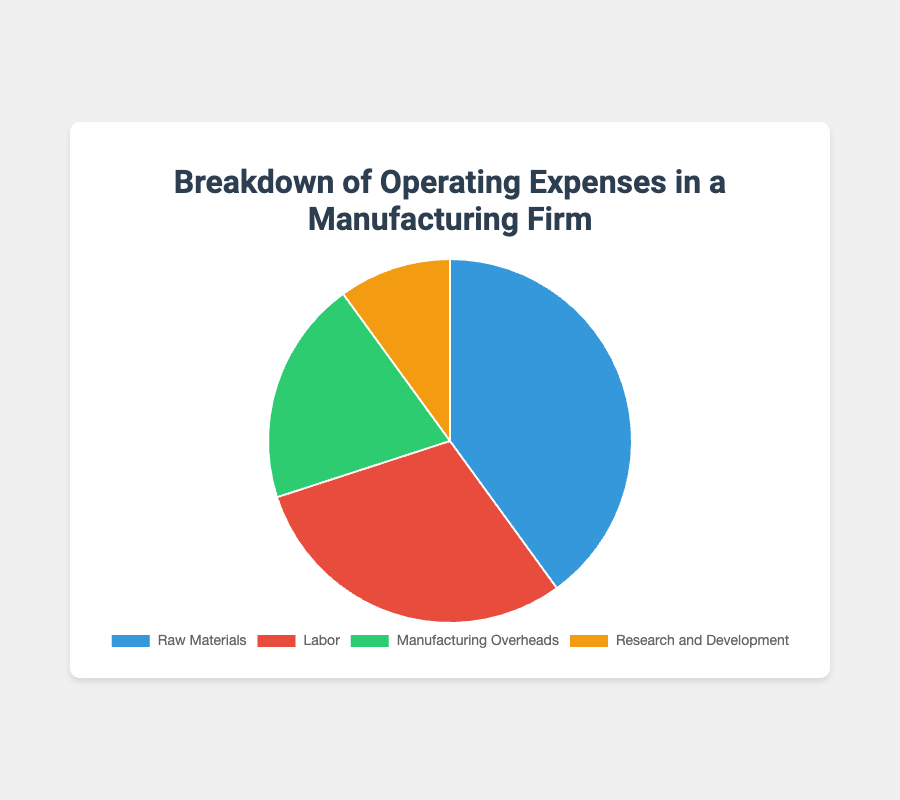What percentage of the total operating expenses is attributed to Labor and Research and Development combined? First, find the percentages for Labor (30%) and Research and Development (10%). Then, sum these percentages: 30% + 10% = 40%.
Answer: 40% Which category accounts for the highest proportion of operating expenses? Look at the percentages for each category and identify the highest value. Raw Materials have the highest percentage at 40%.
Answer: Raw Materials How much more is spent on Raw Materials compared to Manufacturing Overheads? Find the difference between the percentages for Raw Materials (40%) and Manufacturing Overheads (20%): 40% - 20% = 20%.
Answer: 20% Which category is represented by the green color in the pie chart? Look at the dataset and identify that Manufacturing Overheads is assigned the green color.
Answer: Manufacturing Overheads Rank the categories from highest to lowest percentage of operating expenses. List the categories by their given percentages: Raw Materials (40%), Labor (30%), Manufacturing Overheads (20%), Research and Development (10%).
Answer: Raw Materials, Labor, Manufacturing Overheads, Research and Development What is the difference in percentage points between the largest and smallest expense categories? Identify the highest (Raw Materials, 40%) and the lowest (Research and Development, 10%) percentages. Calculate the difference: 40% - 10% = 30%.
Answer: 30% Which two categories together account for half of the total operating expenses? Find two categories that sum to 50%. Labor (30%) and Manufacturing Overheads (20%) together account for 50%: 30% + 20% = 50%.
Answer: Labor and Manufacturing Overheads What is the combined percentage of all categories except Raw Materials? Add the percentages of Labor (30%), Manufacturing Overheads (20%), and Research and Development (10%): 30% + 20% + 10% = 60%.
Answer: 60% If the total operating expenses are $1,000,000, how much is spent on Research and Development? Calculate 10% of $1,000,000: 0.10 * 1,000,000 = $100,000.
Answer: $100,000 How does the proportion of spending on Labor compare to the proportion of spending on Manufacturing Overheads? Compare their percentages: Labor (30%) is more than Manufacturing Overheads (20%).
Answer: Labor is more than Manufacturing Overheads 